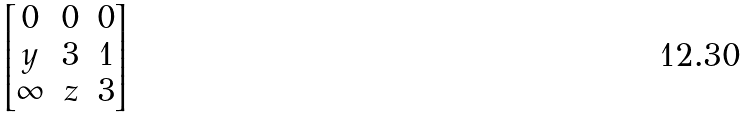Convert formula to latex. <formula><loc_0><loc_0><loc_500><loc_500>\begin{bmatrix} 0 & 0 & 0 \\ y & 3 & 1 \\ \infty & z & 3 \end{bmatrix}</formula> 